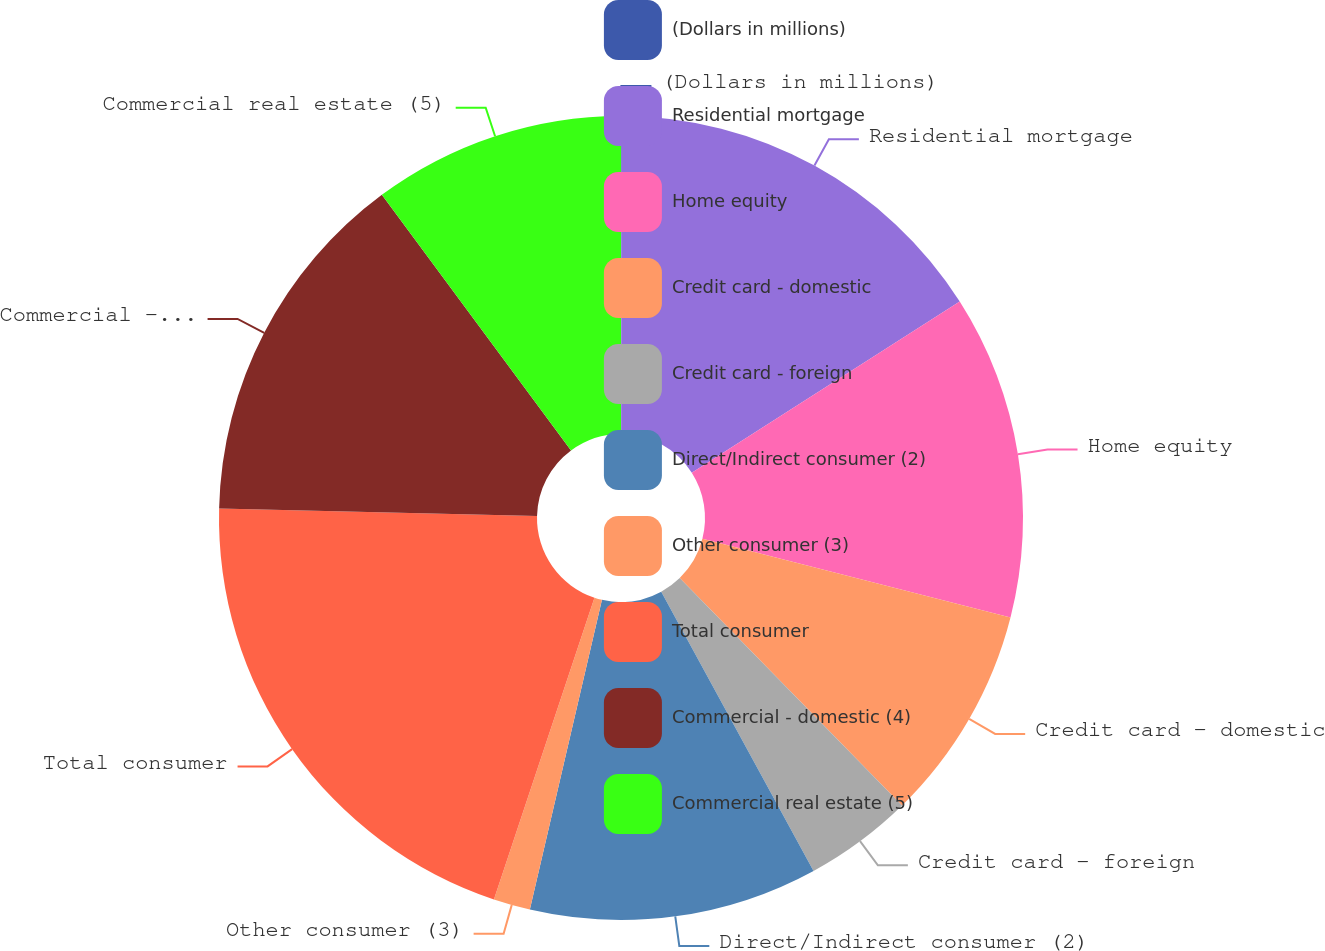Convert chart to OTSL. <chart><loc_0><loc_0><loc_500><loc_500><pie_chart><fcel>(Dollars in millions)<fcel>Residential mortgage<fcel>Home equity<fcel>Credit card - domestic<fcel>Credit card - foreign<fcel>Direct/Indirect consumer (2)<fcel>Other consumer (3)<fcel>Total consumer<fcel>Commercial - domestic (4)<fcel>Commercial real estate (5)<nl><fcel>0.03%<fcel>15.92%<fcel>13.03%<fcel>8.7%<fcel>4.37%<fcel>11.59%<fcel>1.48%<fcel>20.26%<fcel>14.48%<fcel>10.14%<nl></chart> 